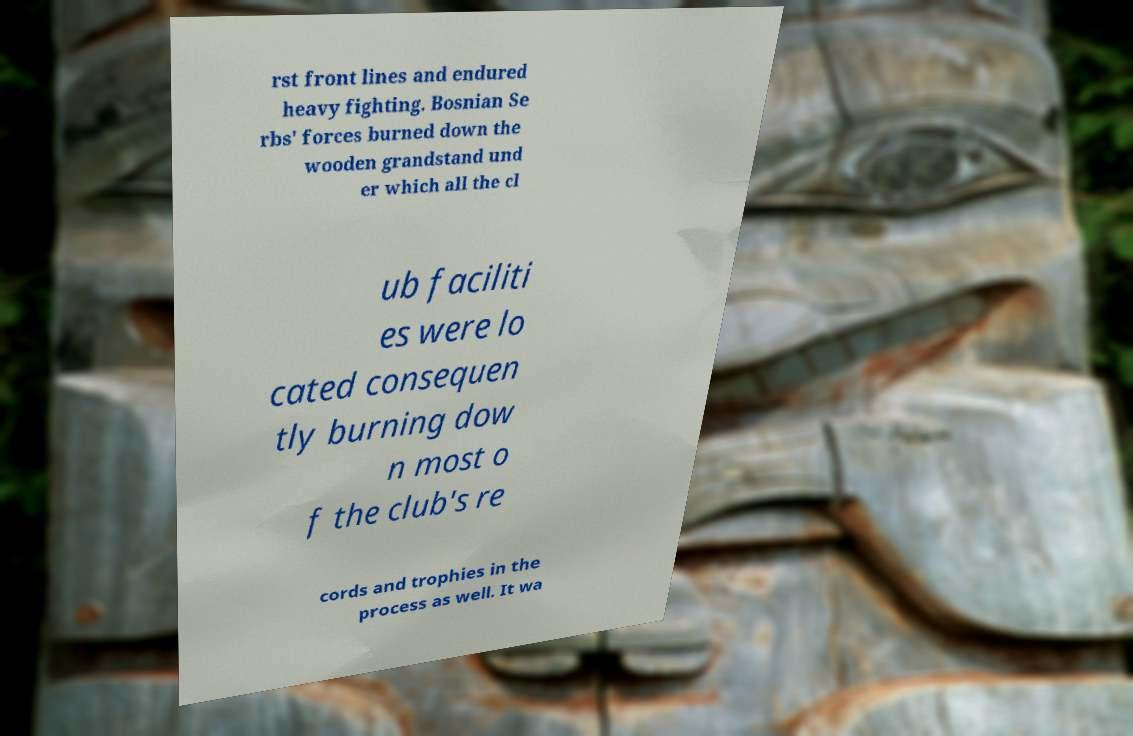Could you extract and type out the text from this image? rst front lines and endured heavy fighting. Bosnian Se rbs' forces burned down the wooden grandstand und er which all the cl ub faciliti es were lo cated consequen tly burning dow n most o f the club's re cords and trophies in the process as well. It wa 